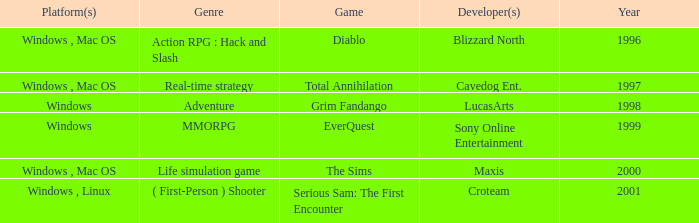What year is the Grim Fandango with a windows platform? 1998.0. 